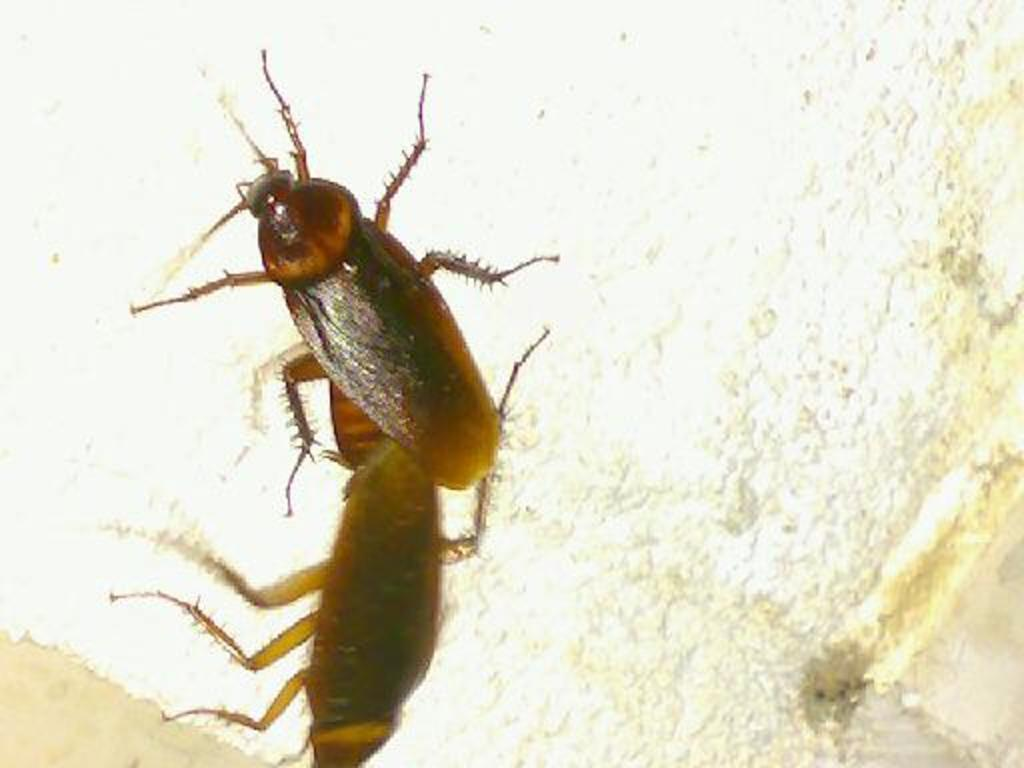What type of insects are present in the image? There are two cockroaches in the image. Where are the cockroaches located? The cockroaches are on a surface. What type of grass can be seen growing in the image? There is no grass present in the image; it features two cockroaches on a surface. What season is depicted in the image, given the presence of winter? The image does not depict any season, as it only shows two cockroaches on a surface. 